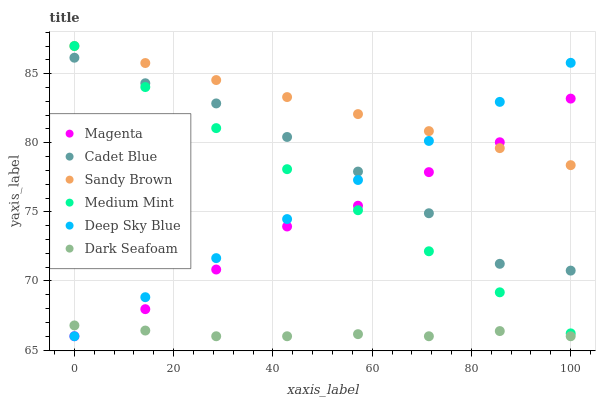Does Dark Seafoam have the minimum area under the curve?
Answer yes or no. Yes. Does Sandy Brown have the maximum area under the curve?
Answer yes or no. Yes. Does Cadet Blue have the minimum area under the curve?
Answer yes or no. No. Does Cadet Blue have the maximum area under the curve?
Answer yes or no. No. Is Medium Mint the smoothest?
Answer yes or no. Yes. Is Cadet Blue the roughest?
Answer yes or no. Yes. Is Dark Seafoam the smoothest?
Answer yes or no. No. Is Dark Seafoam the roughest?
Answer yes or no. No. Does Dark Seafoam have the lowest value?
Answer yes or no. Yes. Does Cadet Blue have the lowest value?
Answer yes or no. No. Does Sandy Brown have the highest value?
Answer yes or no. Yes. Does Cadet Blue have the highest value?
Answer yes or no. No. Is Cadet Blue less than Sandy Brown?
Answer yes or no. Yes. Is Cadet Blue greater than Dark Seafoam?
Answer yes or no. Yes. Does Medium Mint intersect Magenta?
Answer yes or no. Yes. Is Medium Mint less than Magenta?
Answer yes or no. No. Is Medium Mint greater than Magenta?
Answer yes or no. No. Does Cadet Blue intersect Sandy Brown?
Answer yes or no. No. 